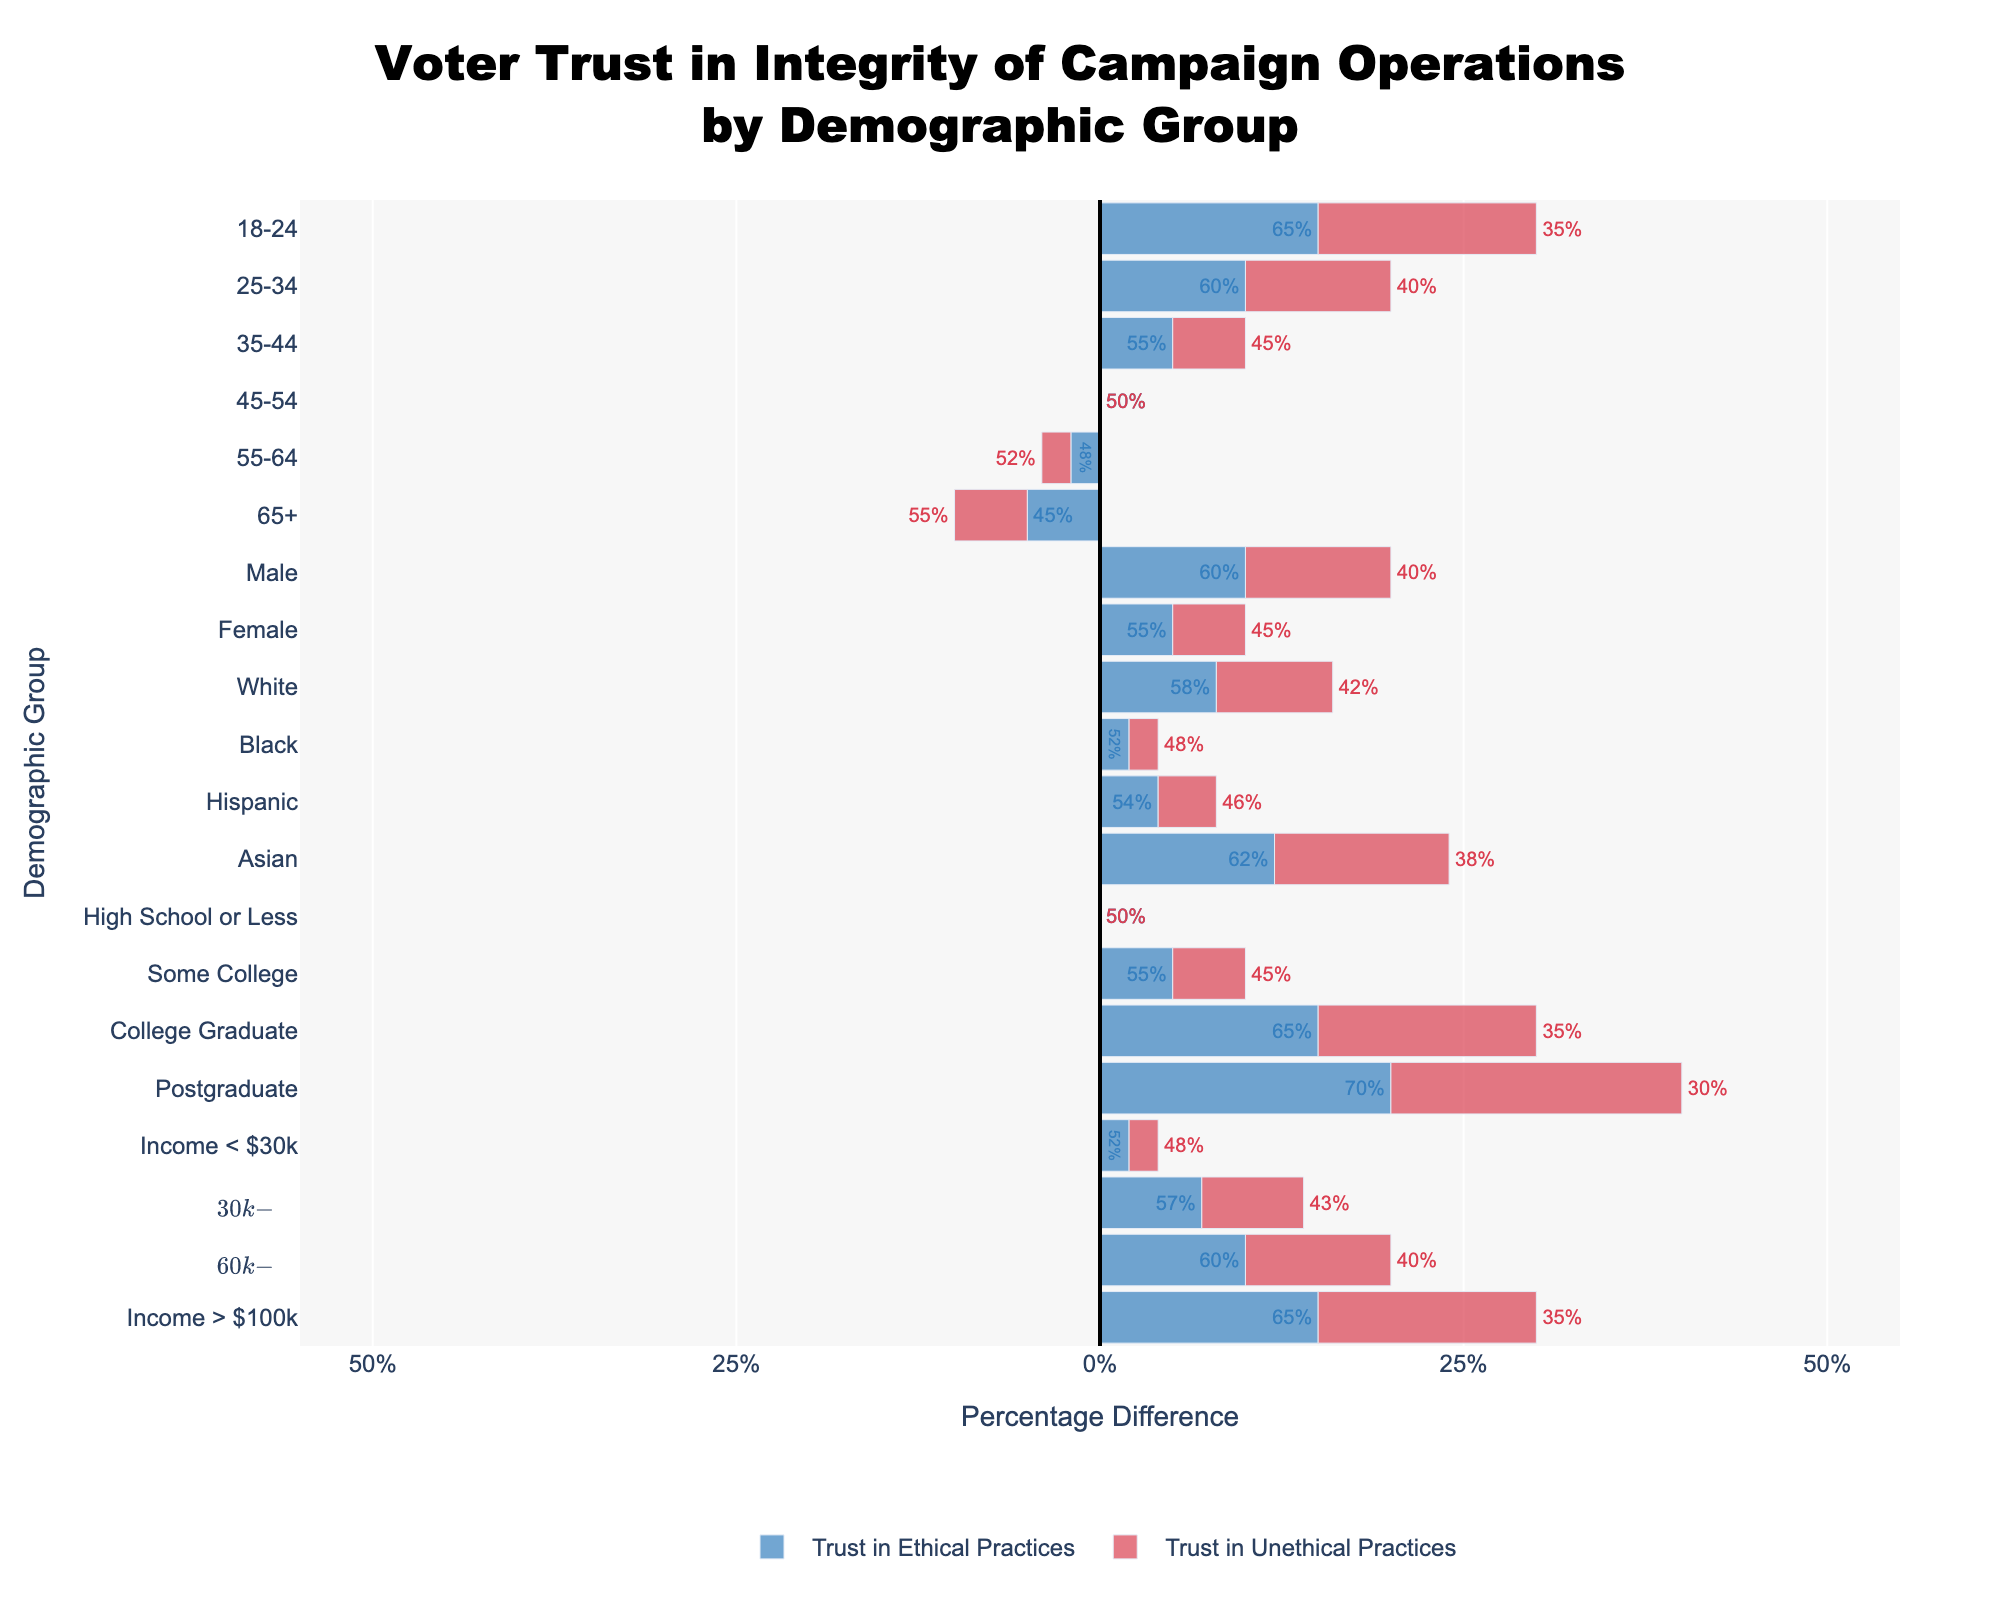Which demographic group has the highest trust in ethical practices? Look at the bar that extends furthest to the right for the blue bars representing trust in ethical practices. The "Postgraduate" group has the longest bar.
Answer: Postgraduate Which demographic group has the lowest trust in ethical practices? Look at the bar that extends the least to the right for the blue bars. The "65+" group shows the least extension.
Answer: 65+ What is the difference in trust in ethical practices between 'College Graduate' and 'High School or Less'? The 'College Graduate' group has 65%, and the 'High School or Less' group has 50% trust in ethical practices. The difference is 65% - 50%.
Answer: 15% Which gender group demonstrates more trust in ethical practices? Compare the lengths of the blue bars for "Male" and "Female." The "Male" group has a slightly longer blue bar.
Answer: Male How does voter trust in ethical practices compare between the age groups 18-24 and 65+? The 18-24 age group has 65% trust, while the 65+ age group has 45% trust. Calculate the difference by subtracting 45% from 65%.
Answer: 20% Which ethnic group has the highest trust in ethical practices? Among the ethnic groups—White, Black, Hispanic, and Asian—the "Asian" group has the longest blue bar.
Answer: Asian Calculate the average trust in ethical practices for the age groups listed. The percentages for age groups are 65%, 60%, 55%, 50%, 48%, and 45%. Sum them up: 65 + 60 + 55 + 50 + 48 + 45 = 323. Then divide by the number of groups (6).
Answer: 53.83% Which demographic group shows an equal trust in ethical and unethical practices? Look for the fact that blue and red bars cross zero symmetrically. The "45-54" and "High School or Less" groups both show this equal trust.
Answer: 45-54 and High School or Less Which income group has the highest trust in unethical practices? Look at the red bars, and find the group whose bar extends furthest to the left. The "$30k" income group has the longest red bar.
Answer: Income < $30k 